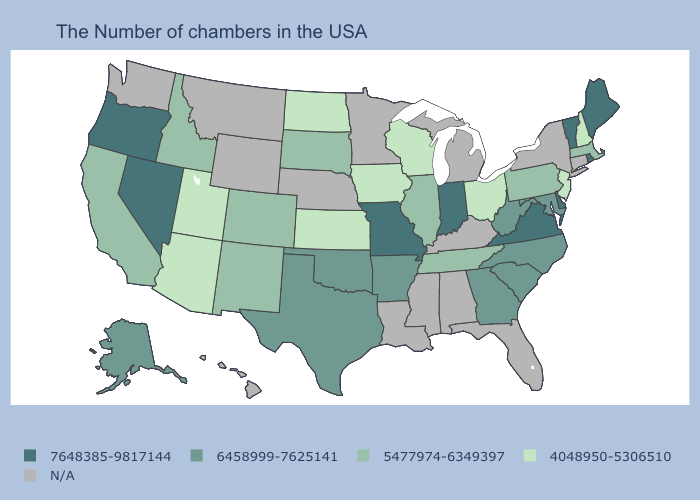Which states have the lowest value in the West?
Keep it brief. Utah, Arizona. Among the states that border Massachusetts , does New Hampshire have the highest value?
Be succinct. No. What is the highest value in the USA?
Be succinct. 7648385-9817144. What is the value of Connecticut?
Concise answer only. N/A. What is the highest value in the USA?
Short answer required. 7648385-9817144. Among the states that border Massachusetts , does New Hampshire have the lowest value?
Quick response, please. Yes. Which states have the highest value in the USA?
Write a very short answer. Maine, Rhode Island, Vermont, Delaware, Virginia, Indiana, Missouri, Nevada, Oregon. Does Ohio have the lowest value in the USA?
Be succinct. Yes. Does Rhode Island have the highest value in the Northeast?
Concise answer only. Yes. Does South Carolina have the lowest value in the South?
Answer briefly. No. Does the first symbol in the legend represent the smallest category?
Quick response, please. No. Does the map have missing data?
Keep it brief. Yes. Among the states that border New Mexico , does Utah have the highest value?
Be succinct. No. Among the states that border South Carolina , which have the lowest value?
Concise answer only. North Carolina, Georgia. What is the value of Louisiana?
Short answer required. N/A. 